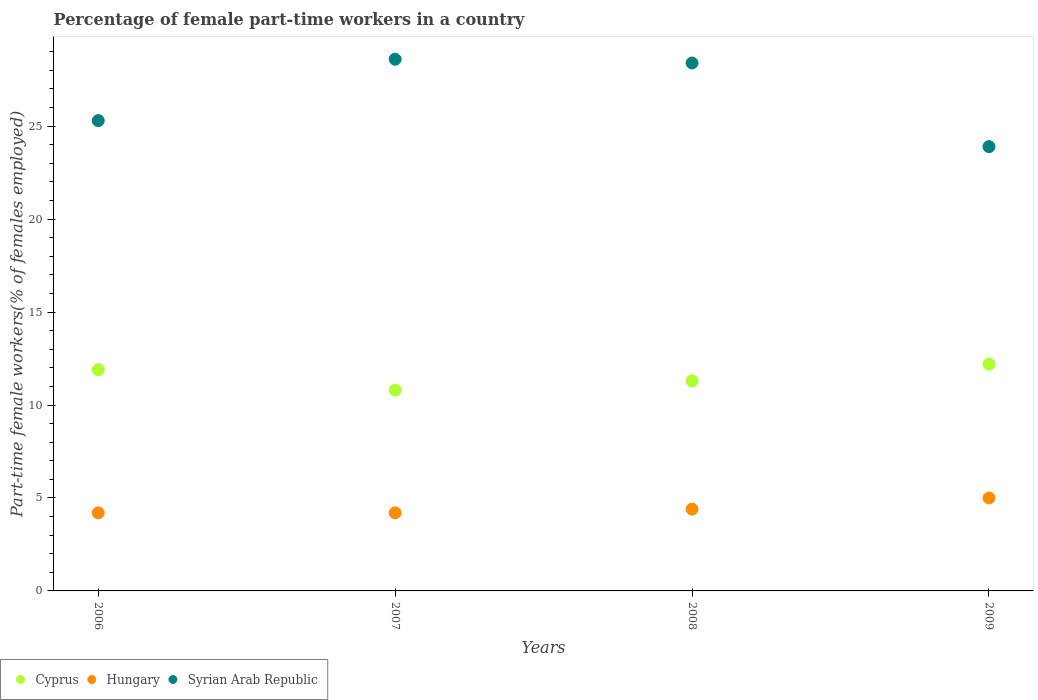What is the percentage of female part-time workers in Hungary in 2006?
Provide a succinct answer. 4.2. Across all years, what is the minimum percentage of female part-time workers in Cyprus?
Your response must be concise. 10.8. In which year was the percentage of female part-time workers in Cyprus maximum?
Your answer should be compact. 2009. What is the total percentage of female part-time workers in Hungary in the graph?
Offer a terse response. 17.8. What is the difference between the percentage of female part-time workers in Syrian Arab Republic in 2006 and that in 2009?
Your answer should be very brief. 1.4. What is the difference between the percentage of female part-time workers in Hungary in 2006 and the percentage of female part-time workers in Cyprus in 2009?
Offer a terse response. -8. What is the average percentage of female part-time workers in Hungary per year?
Your answer should be compact. 4.45. In the year 2007, what is the difference between the percentage of female part-time workers in Cyprus and percentage of female part-time workers in Syrian Arab Republic?
Make the answer very short. -17.8. What is the ratio of the percentage of female part-time workers in Syrian Arab Republic in 2007 to that in 2009?
Offer a terse response. 1.2. Is the difference between the percentage of female part-time workers in Cyprus in 2006 and 2007 greater than the difference between the percentage of female part-time workers in Syrian Arab Republic in 2006 and 2007?
Provide a succinct answer. Yes. What is the difference between the highest and the second highest percentage of female part-time workers in Syrian Arab Republic?
Provide a succinct answer. 0.2. What is the difference between the highest and the lowest percentage of female part-time workers in Syrian Arab Republic?
Your answer should be compact. 4.7. Is the percentage of female part-time workers in Cyprus strictly less than the percentage of female part-time workers in Hungary over the years?
Your answer should be compact. No. How many years are there in the graph?
Provide a short and direct response. 4. Are the values on the major ticks of Y-axis written in scientific E-notation?
Offer a very short reply. No. Does the graph contain any zero values?
Give a very brief answer. No. Does the graph contain grids?
Ensure brevity in your answer.  No. Where does the legend appear in the graph?
Keep it short and to the point. Bottom left. How many legend labels are there?
Keep it short and to the point. 3. What is the title of the graph?
Your answer should be compact. Percentage of female part-time workers in a country. What is the label or title of the Y-axis?
Offer a terse response. Part-time female workers(% of females employed). What is the Part-time female workers(% of females employed) of Cyprus in 2006?
Make the answer very short. 11.9. What is the Part-time female workers(% of females employed) in Hungary in 2006?
Your answer should be compact. 4.2. What is the Part-time female workers(% of females employed) of Syrian Arab Republic in 2006?
Ensure brevity in your answer.  25.3. What is the Part-time female workers(% of females employed) of Cyprus in 2007?
Your response must be concise. 10.8. What is the Part-time female workers(% of females employed) of Hungary in 2007?
Provide a succinct answer. 4.2. What is the Part-time female workers(% of females employed) of Syrian Arab Republic in 2007?
Keep it short and to the point. 28.6. What is the Part-time female workers(% of females employed) of Cyprus in 2008?
Provide a short and direct response. 11.3. What is the Part-time female workers(% of females employed) of Hungary in 2008?
Your response must be concise. 4.4. What is the Part-time female workers(% of females employed) of Syrian Arab Republic in 2008?
Offer a very short reply. 28.4. What is the Part-time female workers(% of females employed) of Cyprus in 2009?
Your answer should be compact. 12.2. What is the Part-time female workers(% of females employed) in Hungary in 2009?
Provide a succinct answer. 5. What is the Part-time female workers(% of females employed) of Syrian Arab Republic in 2009?
Ensure brevity in your answer.  23.9. Across all years, what is the maximum Part-time female workers(% of females employed) of Cyprus?
Offer a very short reply. 12.2. Across all years, what is the maximum Part-time female workers(% of females employed) of Syrian Arab Republic?
Make the answer very short. 28.6. Across all years, what is the minimum Part-time female workers(% of females employed) of Cyprus?
Your response must be concise. 10.8. Across all years, what is the minimum Part-time female workers(% of females employed) in Hungary?
Your answer should be very brief. 4.2. Across all years, what is the minimum Part-time female workers(% of females employed) in Syrian Arab Republic?
Keep it short and to the point. 23.9. What is the total Part-time female workers(% of females employed) in Cyprus in the graph?
Your response must be concise. 46.2. What is the total Part-time female workers(% of females employed) in Hungary in the graph?
Offer a terse response. 17.8. What is the total Part-time female workers(% of females employed) in Syrian Arab Republic in the graph?
Provide a succinct answer. 106.2. What is the difference between the Part-time female workers(% of females employed) in Cyprus in 2006 and that in 2007?
Your response must be concise. 1.1. What is the difference between the Part-time female workers(% of females employed) in Hungary in 2006 and that in 2007?
Your response must be concise. 0. What is the difference between the Part-time female workers(% of females employed) in Syrian Arab Republic in 2006 and that in 2007?
Your answer should be compact. -3.3. What is the difference between the Part-time female workers(% of females employed) of Cyprus in 2006 and that in 2008?
Ensure brevity in your answer.  0.6. What is the difference between the Part-time female workers(% of females employed) in Cyprus in 2006 and that in 2009?
Offer a very short reply. -0.3. What is the difference between the Part-time female workers(% of females employed) of Cyprus in 2007 and that in 2008?
Provide a short and direct response. -0.5. What is the difference between the Part-time female workers(% of females employed) in Hungary in 2007 and that in 2008?
Your response must be concise. -0.2. What is the difference between the Part-time female workers(% of females employed) in Syrian Arab Republic in 2007 and that in 2008?
Your response must be concise. 0.2. What is the difference between the Part-time female workers(% of females employed) in Cyprus in 2007 and that in 2009?
Keep it short and to the point. -1.4. What is the difference between the Part-time female workers(% of females employed) in Hungary in 2007 and that in 2009?
Offer a very short reply. -0.8. What is the difference between the Part-time female workers(% of females employed) in Hungary in 2008 and that in 2009?
Ensure brevity in your answer.  -0.6. What is the difference between the Part-time female workers(% of females employed) of Syrian Arab Republic in 2008 and that in 2009?
Offer a terse response. 4.5. What is the difference between the Part-time female workers(% of females employed) in Cyprus in 2006 and the Part-time female workers(% of females employed) in Syrian Arab Republic in 2007?
Make the answer very short. -16.7. What is the difference between the Part-time female workers(% of females employed) of Hungary in 2006 and the Part-time female workers(% of females employed) of Syrian Arab Republic in 2007?
Your answer should be compact. -24.4. What is the difference between the Part-time female workers(% of females employed) of Cyprus in 2006 and the Part-time female workers(% of females employed) of Hungary in 2008?
Your answer should be compact. 7.5. What is the difference between the Part-time female workers(% of females employed) in Cyprus in 2006 and the Part-time female workers(% of females employed) in Syrian Arab Republic in 2008?
Ensure brevity in your answer.  -16.5. What is the difference between the Part-time female workers(% of females employed) of Hungary in 2006 and the Part-time female workers(% of females employed) of Syrian Arab Republic in 2008?
Provide a succinct answer. -24.2. What is the difference between the Part-time female workers(% of females employed) of Cyprus in 2006 and the Part-time female workers(% of females employed) of Hungary in 2009?
Your answer should be compact. 6.9. What is the difference between the Part-time female workers(% of females employed) of Hungary in 2006 and the Part-time female workers(% of females employed) of Syrian Arab Republic in 2009?
Your response must be concise. -19.7. What is the difference between the Part-time female workers(% of females employed) in Cyprus in 2007 and the Part-time female workers(% of females employed) in Hungary in 2008?
Provide a short and direct response. 6.4. What is the difference between the Part-time female workers(% of females employed) of Cyprus in 2007 and the Part-time female workers(% of females employed) of Syrian Arab Republic in 2008?
Provide a short and direct response. -17.6. What is the difference between the Part-time female workers(% of females employed) of Hungary in 2007 and the Part-time female workers(% of females employed) of Syrian Arab Republic in 2008?
Give a very brief answer. -24.2. What is the difference between the Part-time female workers(% of females employed) of Cyprus in 2007 and the Part-time female workers(% of females employed) of Hungary in 2009?
Offer a very short reply. 5.8. What is the difference between the Part-time female workers(% of females employed) in Cyprus in 2007 and the Part-time female workers(% of females employed) in Syrian Arab Republic in 2009?
Provide a short and direct response. -13.1. What is the difference between the Part-time female workers(% of females employed) of Hungary in 2007 and the Part-time female workers(% of females employed) of Syrian Arab Republic in 2009?
Offer a terse response. -19.7. What is the difference between the Part-time female workers(% of females employed) in Hungary in 2008 and the Part-time female workers(% of females employed) in Syrian Arab Republic in 2009?
Offer a very short reply. -19.5. What is the average Part-time female workers(% of females employed) in Cyprus per year?
Make the answer very short. 11.55. What is the average Part-time female workers(% of females employed) of Hungary per year?
Offer a very short reply. 4.45. What is the average Part-time female workers(% of females employed) in Syrian Arab Republic per year?
Provide a short and direct response. 26.55. In the year 2006, what is the difference between the Part-time female workers(% of females employed) in Hungary and Part-time female workers(% of females employed) in Syrian Arab Republic?
Provide a succinct answer. -21.1. In the year 2007, what is the difference between the Part-time female workers(% of females employed) in Cyprus and Part-time female workers(% of females employed) in Syrian Arab Republic?
Make the answer very short. -17.8. In the year 2007, what is the difference between the Part-time female workers(% of females employed) of Hungary and Part-time female workers(% of females employed) of Syrian Arab Republic?
Make the answer very short. -24.4. In the year 2008, what is the difference between the Part-time female workers(% of females employed) in Cyprus and Part-time female workers(% of females employed) in Syrian Arab Republic?
Your answer should be very brief. -17.1. In the year 2008, what is the difference between the Part-time female workers(% of females employed) of Hungary and Part-time female workers(% of females employed) of Syrian Arab Republic?
Offer a terse response. -24. In the year 2009, what is the difference between the Part-time female workers(% of females employed) in Cyprus and Part-time female workers(% of females employed) in Hungary?
Ensure brevity in your answer.  7.2. In the year 2009, what is the difference between the Part-time female workers(% of females employed) of Cyprus and Part-time female workers(% of females employed) of Syrian Arab Republic?
Keep it short and to the point. -11.7. In the year 2009, what is the difference between the Part-time female workers(% of females employed) in Hungary and Part-time female workers(% of females employed) in Syrian Arab Republic?
Offer a very short reply. -18.9. What is the ratio of the Part-time female workers(% of females employed) of Cyprus in 2006 to that in 2007?
Your answer should be very brief. 1.1. What is the ratio of the Part-time female workers(% of females employed) of Syrian Arab Republic in 2006 to that in 2007?
Give a very brief answer. 0.88. What is the ratio of the Part-time female workers(% of females employed) in Cyprus in 2006 to that in 2008?
Keep it short and to the point. 1.05. What is the ratio of the Part-time female workers(% of females employed) in Hungary in 2006 to that in 2008?
Keep it short and to the point. 0.95. What is the ratio of the Part-time female workers(% of females employed) in Syrian Arab Republic in 2006 to that in 2008?
Offer a very short reply. 0.89. What is the ratio of the Part-time female workers(% of females employed) of Cyprus in 2006 to that in 2009?
Provide a succinct answer. 0.98. What is the ratio of the Part-time female workers(% of females employed) of Hungary in 2006 to that in 2009?
Offer a terse response. 0.84. What is the ratio of the Part-time female workers(% of females employed) in Syrian Arab Republic in 2006 to that in 2009?
Offer a terse response. 1.06. What is the ratio of the Part-time female workers(% of females employed) of Cyprus in 2007 to that in 2008?
Give a very brief answer. 0.96. What is the ratio of the Part-time female workers(% of females employed) in Hungary in 2007 to that in 2008?
Offer a terse response. 0.95. What is the ratio of the Part-time female workers(% of females employed) of Syrian Arab Republic in 2007 to that in 2008?
Offer a terse response. 1.01. What is the ratio of the Part-time female workers(% of females employed) in Cyprus in 2007 to that in 2009?
Make the answer very short. 0.89. What is the ratio of the Part-time female workers(% of females employed) in Hungary in 2007 to that in 2009?
Ensure brevity in your answer.  0.84. What is the ratio of the Part-time female workers(% of females employed) in Syrian Arab Republic in 2007 to that in 2009?
Give a very brief answer. 1.2. What is the ratio of the Part-time female workers(% of females employed) in Cyprus in 2008 to that in 2009?
Make the answer very short. 0.93. What is the ratio of the Part-time female workers(% of females employed) of Syrian Arab Republic in 2008 to that in 2009?
Provide a short and direct response. 1.19. What is the difference between the highest and the second highest Part-time female workers(% of females employed) in Cyprus?
Keep it short and to the point. 0.3. What is the difference between the highest and the second highest Part-time female workers(% of females employed) of Hungary?
Ensure brevity in your answer.  0.6. What is the difference between the highest and the second highest Part-time female workers(% of females employed) of Syrian Arab Republic?
Your answer should be compact. 0.2. What is the difference between the highest and the lowest Part-time female workers(% of females employed) in Hungary?
Offer a very short reply. 0.8. What is the difference between the highest and the lowest Part-time female workers(% of females employed) in Syrian Arab Republic?
Ensure brevity in your answer.  4.7. 